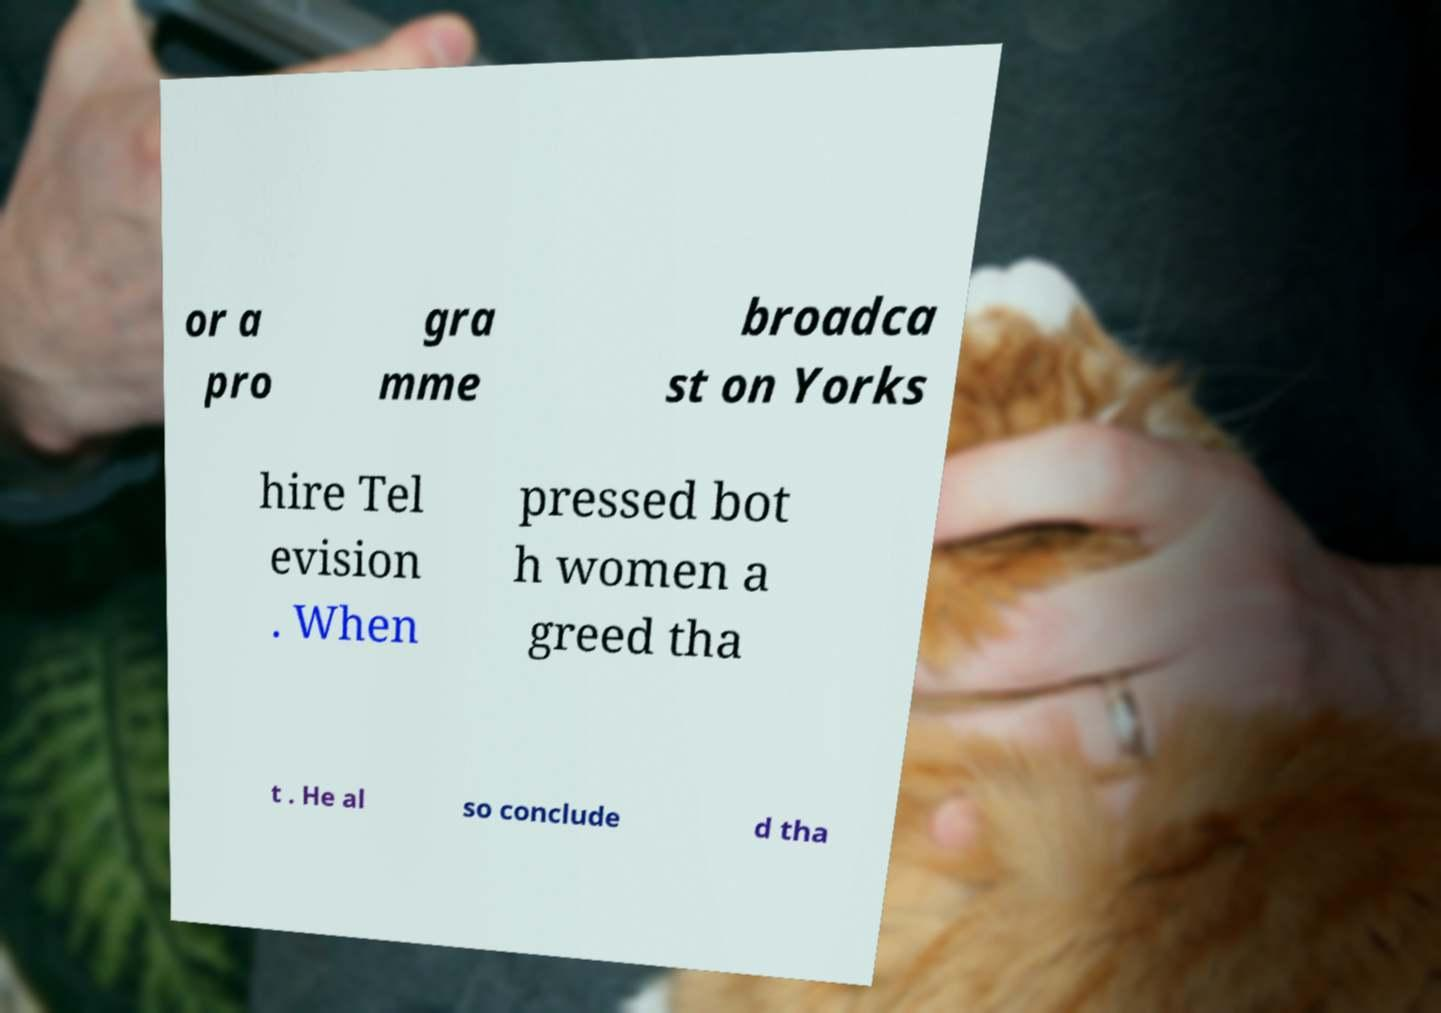Can you accurately transcribe the text from the provided image for me? or a pro gra mme broadca st on Yorks hire Tel evision . When pressed bot h women a greed tha t . He al so conclude d tha 